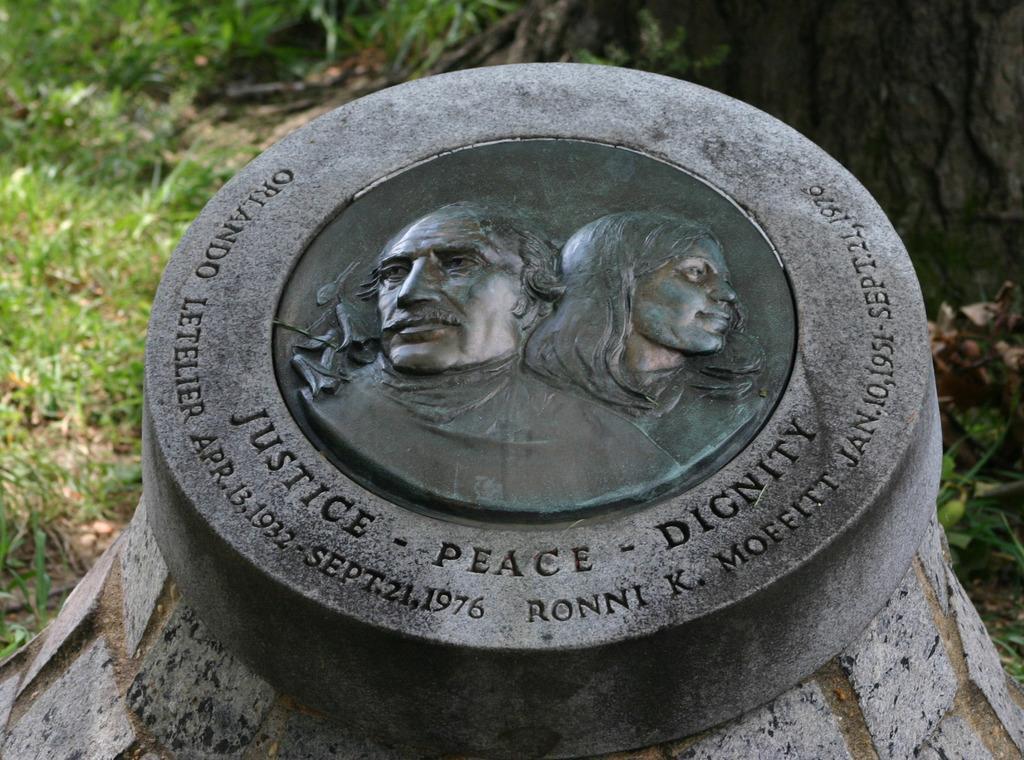How would you summarize this image in a sentence or two? In this picture there is a stone gravity with man and woman picture. In the bottom side we can see "Dignity, peace and Unity" is written. Behind there is a grass. 